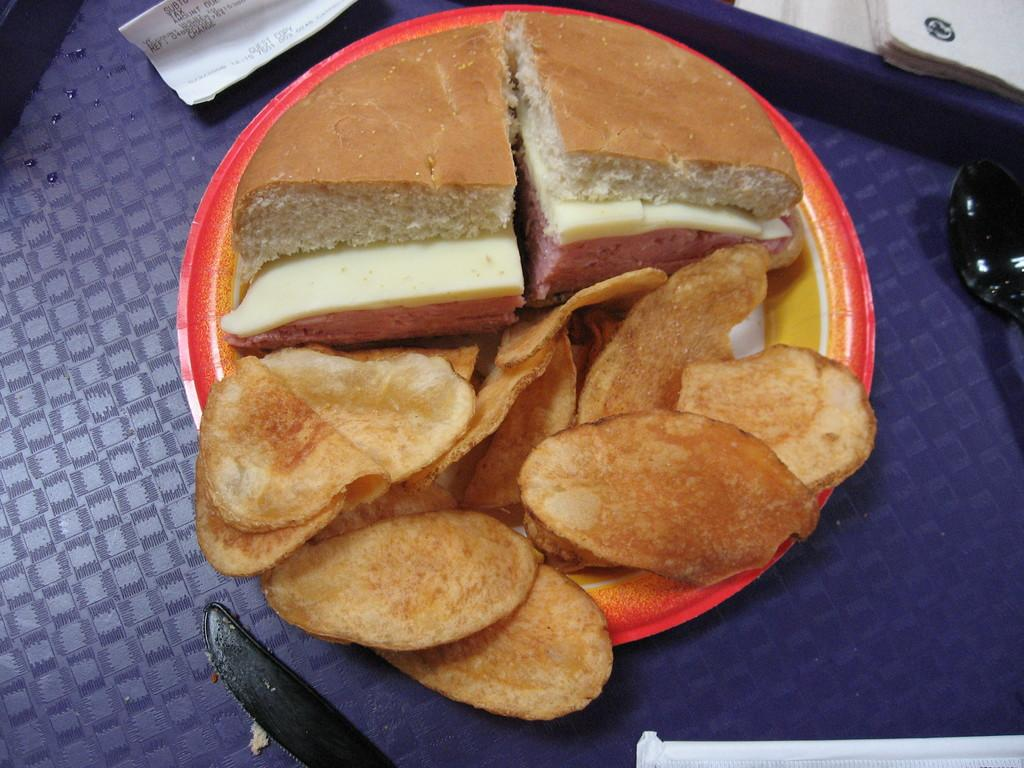What type of food is on the plate in the image? There is bread on a plate in the image. What other type of food is on a plate in the image? There are chips on a plate in the image. Where is the plate with food located? The plate is placed on a table in the image. What else can be seen on the table in the image? There is a paper and books on the table in the image. How does the rainstorm affect the bread and chips on the table in the image? There is no rainstorm present in the image, so it does not affect the bread and chips. 